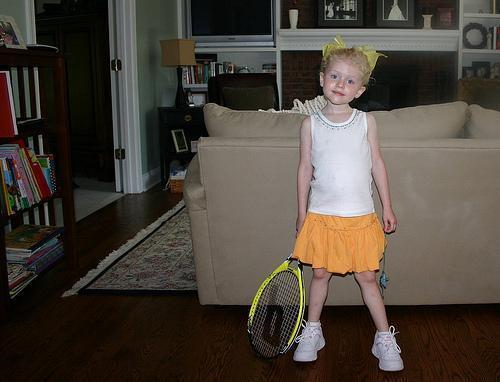How many windows are seen in the picture?
Give a very brief answer. 1. How many photos are visible in the photo?
Give a very brief answer. 5. How many people are in the living room?
Give a very brief answer. 1. How many shoes are floating haphazardly?
Give a very brief answer. 0. 